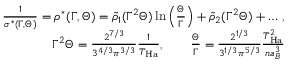<formula> <loc_0><loc_0><loc_500><loc_500>\begin{array} { r l r } & { \frac { 1 } { \sigma ^ { * } ( \Gamma , \Theta ) } = \rho ^ { * } ( \Gamma , \Theta ) = \tilde { \rho } _ { 1 } ( \Gamma ^ { 2 } \Theta ) \ln \left ( \frac { \Theta } { \Gamma } \right ) + \tilde { \rho } _ { 2 } ( \Gamma ^ { 2 } \Theta ) + \dots \, , } \\ & { \Gamma ^ { 2 } \Theta = \frac { 2 ^ { 7 / 3 } } { 3 ^ { 4 / 3 } \pi ^ { 3 / 3 } } \frac { 1 } { T _ { H a } } , \quad \frac { \Theta } { \Gamma } = \frac { 2 ^ { 1 / 3 } } { 3 ^ { 1 / 3 } \pi ^ { 5 / 3 } } \frac { T _ { H a } ^ { 2 } } { n a _ { B } ^ { 3 } } } \end{array}</formula> 